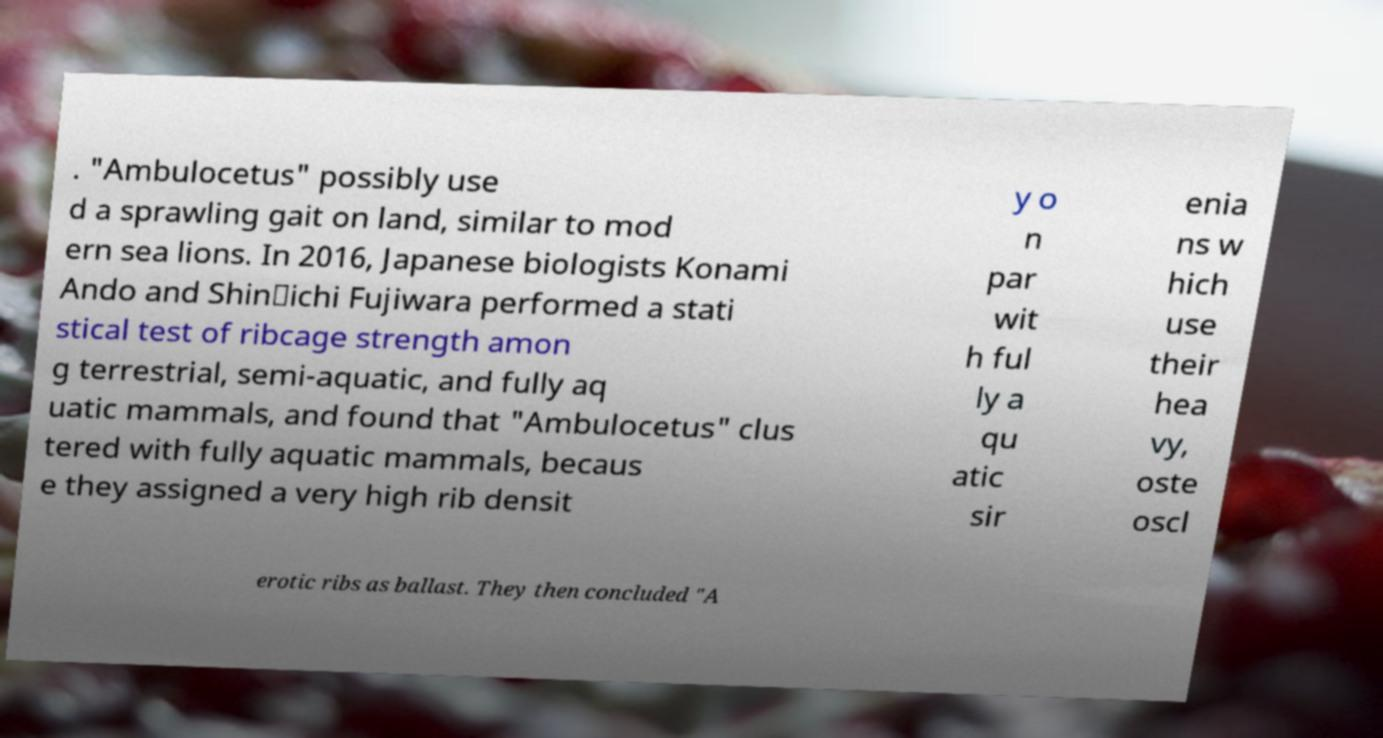Please read and relay the text visible in this image. What does it say? . "Ambulocetus" possibly use d a sprawling gait on land, similar to mod ern sea lions. In 2016, Japanese biologists Konami Ando and Shin‐ichi Fujiwara performed a stati stical test of ribcage strength amon g terrestrial, semi-aquatic, and fully aq uatic mammals, and found that "Ambulocetus" clus tered with fully aquatic mammals, becaus e they assigned a very high rib densit y o n par wit h ful ly a qu atic sir enia ns w hich use their hea vy, oste oscl erotic ribs as ballast. They then concluded "A 